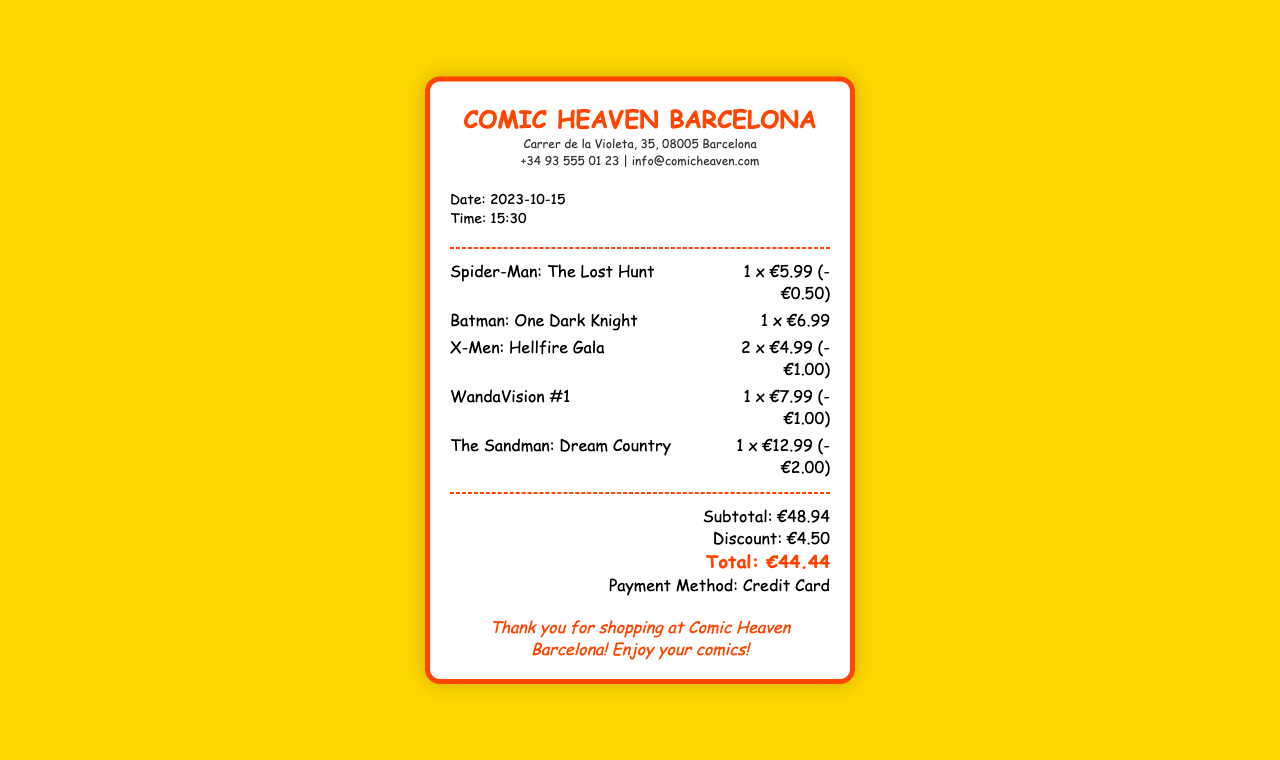What is the date of purchase? The date of purchase is given in the document, listed under purchase info.
Answer: 2023-10-15 What is the total amount spent? The total amount spent is indicated at the bottom of the receipt, showing the final total after discounts.
Answer: €44.44 How much was discounted in total? The total discount is summarized in the totals section of the document.
Answer: €4.50 What is the name of the first comic listed? The first comic listed in the items section provides the title of the comic.
Answer: Spider-Man: The Lost Hunt How many X-Men: Hellfire Gala comics were purchased? The quantity of X-Men: Hellfire Gala comics is specified in the item details.
Answer: 2 What was the payment method used? The payment method is specified in the totals section of the receipt.
Answer: Credit Card Which comic had the highest price? The highest price is found by comparing the item prices listed on the receipt.
Answer: The Sandman: Dream Country How much was the discount on WandaVision #1? The discount for WandaVision #1 is mentioned specifically in its item detail.
Answer: -€1.00 What time was the purchase made? The time of purchase is provided in the purchase info section of the document.
Answer: 15:30 